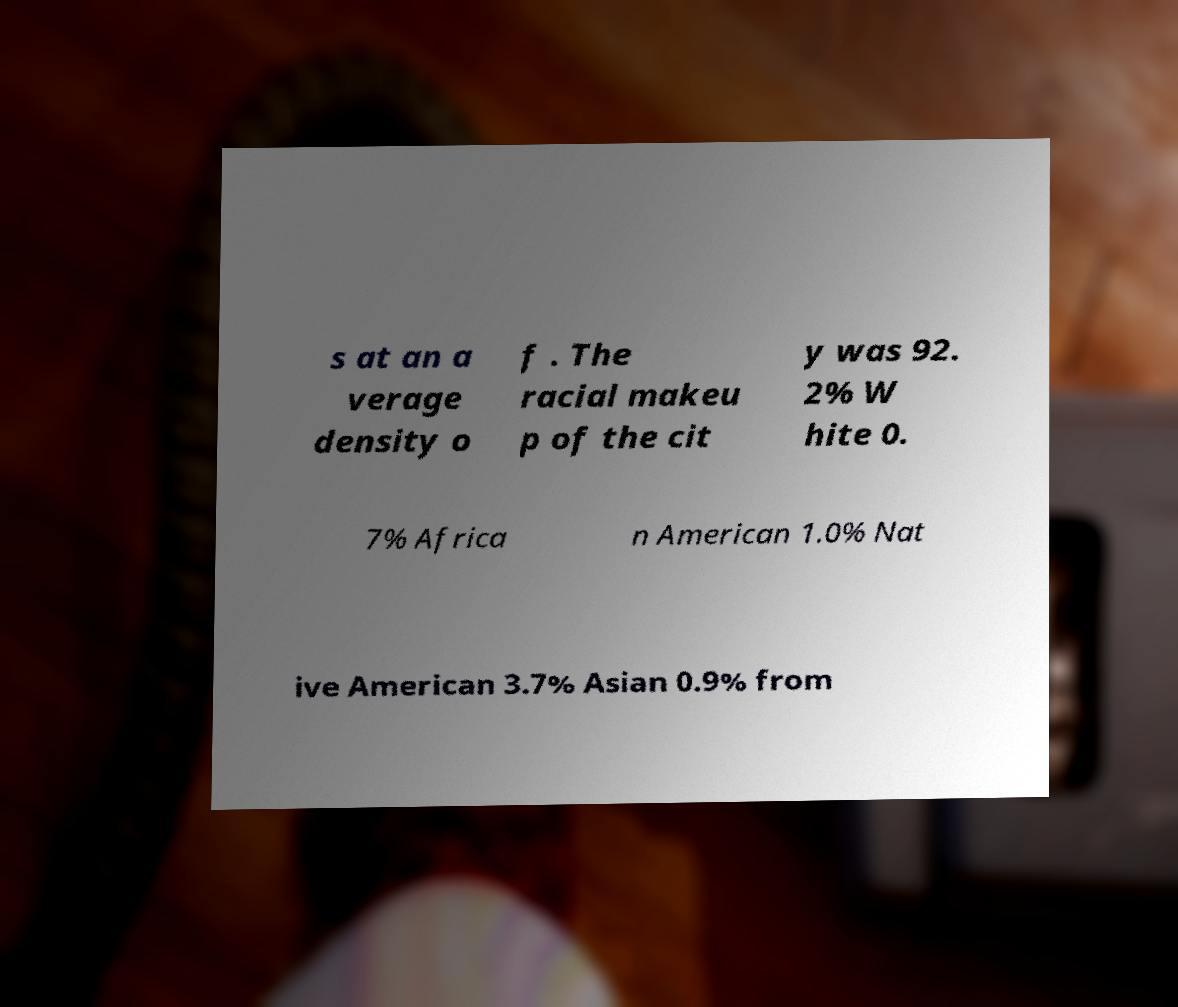Please read and relay the text visible in this image. What does it say? s at an a verage density o f . The racial makeu p of the cit y was 92. 2% W hite 0. 7% Africa n American 1.0% Nat ive American 3.7% Asian 0.9% from 